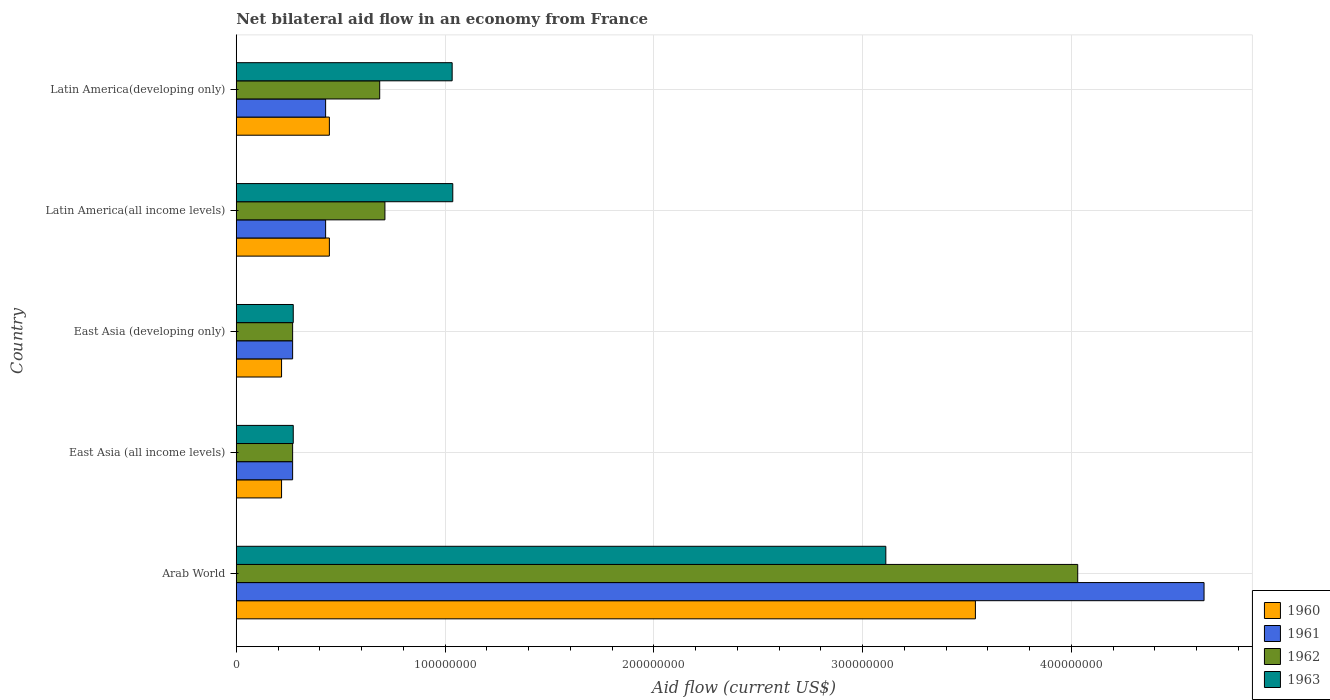How many bars are there on the 2nd tick from the top?
Make the answer very short. 4. How many bars are there on the 2nd tick from the bottom?
Your response must be concise. 4. What is the label of the 4th group of bars from the top?
Your answer should be compact. East Asia (all income levels). What is the net bilateral aid flow in 1962 in East Asia (all income levels)?
Offer a terse response. 2.70e+07. Across all countries, what is the maximum net bilateral aid flow in 1962?
Ensure brevity in your answer.  4.03e+08. Across all countries, what is the minimum net bilateral aid flow in 1960?
Offer a very short reply. 2.17e+07. In which country was the net bilateral aid flow in 1960 maximum?
Your answer should be very brief. Arab World. In which country was the net bilateral aid flow in 1960 minimum?
Give a very brief answer. East Asia (all income levels). What is the total net bilateral aid flow in 1962 in the graph?
Your response must be concise. 5.97e+08. What is the difference between the net bilateral aid flow in 1961 in East Asia (all income levels) and that in Latin America(all income levels)?
Provide a succinct answer. -1.58e+07. What is the difference between the net bilateral aid flow in 1963 in Arab World and the net bilateral aid flow in 1960 in East Asia (all income levels)?
Give a very brief answer. 2.89e+08. What is the average net bilateral aid flow in 1960 per country?
Your answer should be very brief. 9.73e+07. What is the difference between the net bilateral aid flow in 1961 and net bilateral aid flow in 1962 in East Asia (developing only)?
Your response must be concise. 0. What is the ratio of the net bilateral aid flow in 1960 in East Asia (all income levels) to that in East Asia (developing only)?
Your answer should be very brief. 1. Is the net bilateral aid flow in 1960 in Latin America(all income levels) less than that in Latin America(developing only)?
Provide a short and direct response. No. What is the difference between the highest and the second highest net bilateral aid flow in 1961?
Give a very brief answer. 4.21e+08. What is the difference between the highest and the lowest net bilateral aid flow in 1962?
Provide a succinct answer. 3.76e+08. What does the 2nd bar from the bottom in East Asia (developing only) represents?
Provide a short and direct response. 1961. What is the difference between two consecutive major ticks on the X-axis?
Make the answer very short. 1.00e+08. Does the graph contain grids?
Provide a succinct answer. Yes. How many legend labels are there?
Your answer should be very brief. 4. What is the title of the graph?
Your answer should be compact. Net bilateral aid flow in an economy from France. Does "1981" appear as one of the legend labels in the graph?
Provide a short and direct response. No. What is the label or title of the X-axis?
Keep it short and to the point. Aid flow (current US$). What is the label or title of the Y-axis?
Offer a terse response. Country. What is the Aid flow (current US$) in 1960 in Arab World?
Keep it short and to the point. 3.54e+08. What is the Aid flow (current US$) in 1961 in Arab World?
Your answer should be compact. 4.64e+08. What is the Aid flow (current US$) in 1962 in Arab World?
Ensure brevity in your answer.  4.03e+08. What is the Aid flow (current US$) in 1963 in Arab World?
Ensure brevity in your answer.  3.11e+08. What is the Aid flow (current US$) in 1960 in East Asia (all income levels)?
Ensure brevity in your answer.  2.17e+07. What is the Aid flow (current US$) of 1961 in East Asia (all income levels)?
Make the answer very short. 2.70e+07. What is the Aid flow (current US$) in 1962 in East Asia (all income levels)?
Provide a succinct answer. 2.70e+07. What is the Aid flow (current US$) in 1963 in East Asia (all income levels)?
Make the answer very short. 2.73e+07. What is the Aid flow (current US$) of 1960 in East Asia (developing only)?
Make the answer very short. 2.17e+07. What is the Aid flow (current US$) in 1961 in East Asia (developing only)?
Provide a succinct answer. 2.70e+07. What is the Aid flow (current US$) in 1962 in East Asia (developing only)?
Give a very brief answer. 2.70e+07. What is the Aid flow (current US$) in 1963 in East Asia (developing only)?
Your answer should be compact. 2.73e+07. What is the Aid flow (current US$) of 1960 in Latin America(all income levels)?
Make the answer very short. 4.46e+07. What is the Aid flow (current US$) of 1961 in Latin America(all income levels)?
Ensure brevity in your answer.  4.28e+07. What is the Aid flow (current US$) in 1962 in Latin America(all income levels)?
Offer a very short reply. 7.12e+07. What is the Aid flow (current US$) of 1963 in Latin America(all income levels)?
Your answer should be compact. 1.04e+08. What is the Aid flow (current US$) in 1960 in Latin America(developing only)?
Provide a succinct answer. 4.46e+07. What is the Aid flow (current US$) of 1961 in Latin America(developing only)?
Provide a short and direct response. 4.28e+07. What is the Aid flow (current US$) of 1962 in Latin America(developing only)?
Provide a succinct answer. 6.87e+07. What is the Aid flow (current US$) in 1963 in Latin America(developing only)?
Your answer should be compact. 1.03e+08. Across all countries, what is the maximum Aid flow (current US$) in 1960?
Make the answer very short. 3.54e+08. Across all countries, what is the maximum Aid flow (current US$) of 1961?
Offer a terse response. 4.64e+08. Across all countries, what is the maximum Aid flow (current US$) of 1962?
Give a very brief answer. 4.03e+08. Across all countries, what is the maximum Aid flow (current US$) of 1963?
Make the answer very short. 3.11e+08. Across all countries, what is the minimum Aid flow (current US$) in 1960?
Give a very brief answer. 2.17e+07. Across all countries, what is the minimum Aid flow (current US$) in 1961?
Provide a short and direct response. 2.70e+07. Across all countries, what is the minimum Aid flow (current US$) of 1962?
Your answer should be compact. 2.70e+07. Across all countries, what is the minimum Aid flow (current US$) of 1963?
Offer a terse response. 2.73e+07. What is the total Aid flow (current US$) in 1960 in the graph?
Give a very brief answer. 4.87e+08. What is the total Aid flow (current US$) of 1961 in the graph?
Keep it short and to the point. 6.03e+08. What is the total Aid flow (current US$) in 1962 in the graph?
Make the answer very short. 5.97e+08. What is the total Aid flow (current US$) of 1963 in the graph?
Your answer should be very brief. 5.73e+08. What is the difference between the Aid flow (current US$) of 1960 in Arab World and that in East Asia (all income levels)?
Offer a very short reply. 3.32e+08. What is the difference between the Aid flow (current US$) of 1961 in Arab World and that in East Asia (all income levels)?
Offer a very short reply. 4.36e+08. What is the difference between the Aid flow (current US$) of 1962 in Arab World and that in East Asia (all income levels)?
Provide a succinct answer. 3.76e+08. What is the difference between the Aid flow (current US$) in 1963 in Arab World and that in East Asia (all income levels)?
Give a very brief answer. 2.84e+08. What is the difference between the Aid flow (current US$) in 1960 in Arab World and that in East Asia (developing only)?
Provide a succinct answer. 3.32e+08. What is the difference between the Aid flow (current US$) of 1961 in Arab World and that in East Asia (developing only)?
Your answer should be compact. 4.36e+08. What is the difference between the Aid flow (current US$) in 1962 in Arab World and that in East Asia (developing only)?
Offer a terse response. 3.76e+08. What is the difference between the Aid flow (current US$) of 1963 in Arab World and that in East Asia (developing only)?
Provide a short and direct response. 2.84e+08. What is the difference between the Aid flow (current US$) of 1960 in Arab World and that in Latin America(all income levels)?
Your response must be concise. 3.09e+08. What is the difference between the Aid flow (current US$) in 1961 in Arab World and that in Latin America(all income levels)?
Your response must be concise. 4.21e+08. What is the difference between the Aid flow (current US$) in 1962 in Arab World and that in Latin America(all income levels)?
Provide a succinct answer. 3.32e+08. What is the difference between the Aid flow (current US$) of 1963 in Arab World and that in Latin America(all income levels)?
Your response must be concise. 2.07e+08. What is the difference between the Aid flow (current US$) in 1960 in Arab World and that in Latin America(developing only)?
Provide a short and direct response. 3.09e+08. What is the difference between the Aid flow (current US$) of 1961 in Arab World and that in Latin America(developing only)?
Keep it short and to the point. 4.21e+08. What is the difference between the Aid flow (current US$) of 1962 in Arab World and that in Latin America(developing only)?
Keep it short and to the point. 3.34e+08. What is the difference between the Aid flow (current US$) in 1963 in Arab World and that in Latin America(developing only)?
Your answer should be very brief. 2.08e+08. What is the difference between the Aid flow (current US$) of 1960 in East Asia (all income levels) and that in East Asia (developing only)?
Ensure brevity in your answer.  0. What is the difference between the Aid flow (current US$) in 1961 in East Asia (all income levels) and that in East Asia (developing only)?
Provide a succinct answer. 0. What is the difference between the Aid flow (current US$) of 1962 in East Asia (all income levels) and that in East Asia (developing only)?
Keep it short and to the point. 0. What is the difference between the Aid flow (current US$) of 1963 in East Asia (all income levels) and that in East Asia (developing only)?
Offer a terse response. 0. What is the difference between the Aid flow (current US$) in 1960 in East Asia (all income levels) and that in Latin America(all income levels)?
Give a very brief answer. -2.29e+07. What is the difference between the Aid flow (current US$) in 1961 in East Asia (all income levels) and that in Latin America(all income levels)?
Your answer should be very brief. -1.58e+07. What is the difference between the Aid flow (current US$) in 1962 in East Asia (all income levels) and that in Latin America(all income levels)?
Ensure brevity in your answer.  -4.42e+07. What is the difference between the Aid flow (current US$) of 1963 in East Asia (all income levels) and that in Latin America(all income levels)?
Provide a short and direct response. -7.64e+07. What is the difference between the Aid flow (current US$) in 1960 in East Asia (all income levels) and that in Latin America(developing only)?
Keep it short and to the point. -2.29e+07. What is the difference between the Aid flow (current US$) in 1961 in East Asia (all income levels) and that in Latin America(developing only)?
Your answer should be compact. -1.58e+07. What is the difference between the Aid flow (current US$) in 1962 in East Asia (all income levels) and that in Latin America(developing only)?
Your answer should be very brief. -4.17e+07. What is the difference between the Aid flow (current US$) of 1963 in East Asia (all income levels) and that in Latin America(developing only)?
Your answer should be very brief. -7.61e+07. What is the difference between the Aid flow (current US$) of 1960 in East Asia (developing only) and that in Latin America(all income levels)?
Your answer should be compact. -2.29e+07. What is the difference between the Aid flow (current US$) of 1961 in East Asia (developing only) and that in Latin America(all income levels)?
Provide a short and direct response. -1.58e+07. What is the difference between the Aid flow (current US$) of 1962 in East Asia (developing only) and that in Latin America(all income levels)?
Ensure brevity in your answer.  -4.42e+07. What is the difference between the Aid flow (current US$) in 1963 in East Asia (developing only) and that in Latin America(all income levels)?
Provide a short and direct response. -7.64e+07. What is the difference between the Aid flow (current US$) of 1960 in East Asia (developing only) and that in Latin America(developing only)?
Ensure brevity in your answer.  -2.29e+07. What is the difference between the Aid flow (current US$) of 1961 in East Asia (developing only) and that in Latin America(developing only)?
Provide a succinct answer. -1.58e+07. What is the difference between the Aid flow (current US$) of 1962 in East Asia (developing only) and that in Latin America(developing only)?
Provide a succinct answer. -4.17e+07. What is the difference between the Aid flow (current US$) in 1963 in East Asia (developing only) and that in Latin America(developing only)?
Your answer should be very brief. -7.61e+07. What is the difference between the Aid flow (current US$) of 1960 in Latin America(all income levels) and that in Latin America(developing only)?
Your answer should be compact. 0. What is the difference between the Aid flow (current US$) of 1962 in Latin America(all income levels) and that in Latin America(developing only)?
Ensure brevity in your answer.  2.50e+06. What is the difference between the Aid flow (current US$) of 1960 in Arab World and the Aid flow (current US$) of 1961 in East Asia (all income levels)?
Your response must be concise. 3.27e+08. What is the difference between the Aid flow (current US$) in 1960 in Arab World and the Aid flow (current US$) in 1962 in East Asia (all income levels)?
Keep it short and to the point. 3.27e+08. What is the difference between the Aid flow (current US$) in 1960 in Arab World and the Aid flow (current US$) in 1963 in East Asia (all income levels)?
Provide a short and direct response. 3.27e+08. What is the difference between the Aid flow (current US$) in 1961 in Arab World and the Aid flow (current US$) in 1962 in East Asia (all income levels)?
Give a very brief answer. 4.36e+08. What is the difference between the Aid flow (current US$) of 1961 in Arab World and the Aid flow (current US$) of 1963 in East Asia (all income levels)?
Your answer should be compact. 4.36e+08. What is the difference between the Aid flow (current US$) of 1962 in Arab World and the Aid flow (current US$) of 1963 in East Asia (all income levels)?
Ensure brevity in your answer.  3.76e+08. What is the difference between the Aid flow (current US$) in 1960 in Arab World and the Aid flow (current US$) in 1961 in East Asia (developing only)?
Make the answer very short. 3.27e+08. What is the difference between the Aid flow (current US$) in 1960 in Arab World and the Aid flow (current US$) in 1962 in East Asia (developing only)?
Ensure brevity in your answer.  3.27e+08. What is the difference between the Aid flow (current US$) in 1960 in Arab World and the Aid flow (current US$) in 1963 in East Asia (developing only)?
Your answer should be compact. 3.27e+08. What is the difference between the Aid flow (current US$) in 1961 in Arab World and the Aid flow (current US$) in 1962 in East Asia (developing only)?
Your response must be concise. 4.36e+08. What is the difference between the Aid flow (current US$) in 1961 in Arab World and the Aid flow (current US$) in 1963 in East Asia (developing only)?
Ensure brevity in your answer.  4.36e+08. What is the difference between the Aid flow (current US$) of 1962 in Arab World and the Aid flow (current US$) of 1963 in East Asia (developing only)?
Your response must be concise. 3.76e+08. What is the difference between the Aid flow (current US$) of 1960 in Arab World and the Aid flow (current US$) of 1961 in Latin America(all income levels)?
Keep it short and to the point. 3.11e+08. What is the difference between the Aid flow (current US$) in 1960 in Arab World and the Aid flow (current US$) in 1962 in Latin America(all income levels)?
Provide a short and direct response. 2.83e+08. What is the difference between the Aid flow (current US$) of 1960 in Arab World and the Aid flow (current US$) of 1963 in Latin America(all income levels)?
Offer a terse response. 2.50e+08. What is the difference between the Aid flow (current US$) of 1961 in Arab World and the Aid flow (current US$) of 1962 in Latin America(all income levels)?
Offer a terse response. 3.92e+08. What is the difference between the Aid flow (current US$) of 1961 in Arab World and the Aid flow (current US$) of 1963 in Latin America(all income levels)?
Provide a succinct answer. 3.60e+08. What is the difference between the Aid flow (current US$) of 1962 in Arab World and the Aid flow (current US$) of 1963 in Latin America(all income levels)?
Offer a terse response. 2.99e+08. What is the difference between the Aid flow (current US$) of 1960 in Arab World and the Aid flow (current US$) of 1961 in Latin America(developing only)?
Make the answer very short. 3.11e+08. What is the difference between the Aid flow (current US$) in 1960 in Arab World and the Aid flow (current US$) in 1962 in Latin America(developing only)?
Your answer should be very brief. 2.85e+08. What is the difference between the Aid flow (current US$) of 1960 in Arab World and the Aid flow (current US$) of 1963 in Latin America(developing only)?
Offer a very short reply. 2.51e+08. What is the difference between the Aid flow (current US$) of 1961 in Arab World and the Aid flow (current US$) of 1962 in Latin America(developing only)?
Keep it short and to the point. 3.95e+08. What is the difference between the Aid flow (current US$) in 1961 in Arab World and the Aid flow (current US$) in 1963 in Latin America(developing only)?
Make the answer very short. 3.60e+08. What is the difference between the Aid flow (current US$) in 1962 in Arab World and the Aid flow (current US$) in 1963 in Latin America(developing only)?
Make the answer very short. 3.00e+08. What is the difference between the Aid flow (current US$) of 1960 in East Asia (all income levels) and the Aid flow (current US$) of 1961 in East Asia (developing only)?
Your answer should be very brief. -5.30e+06. What is the difference between the Aid flow (current US$) of 1960 in East Asia (all income levels) and the Aid flow (current US$) of 1962 in East Asia (developing only)?
Your answer should be very brief. -5.30e+06. What is the difference between the Aid flow (current US$) of 1960 in East Asia (all income levels) and the Aid flow (current US$) of 1963 in East Asia (developing only)?
Offer a very short reply. -5.60e+06. What is the difference between the Aid flow (current US$) in 1961 in East Asia (all income levels) and the Aid flow (current US$) in 1963 in East Asia (developing only)?
Your answer should be very brief. -3.00e+05. What is the difference between the Aid flow (current US$) of 1962 in East Asia (all income levels) and the Aid flow (current US$) of 1963 in East Asia (developing only)?
Give a very brief answer. -3.00e+05. What is the difference between the Aid flow (current US$) in 1960 in East Asia (all income levels) and the Aid flow (current US$) in 1961 in Latin America(all income levels)?
Offer a terse response. -2.11e+07. What is the difference between the Aid flow (current US$) of 1960 in East Asia (all income levels) and the Aid flow (current US$) of 1962 in Latin America(all income levels)?
Provide a short and direct response. -4.95e+07. What is the difference between the Aid flow (current US$) of 1960 in East Asia (all income levels) and the Aid flow (current US$) of 1963 in Latin America(all income levels)?
Your response must be concise. -8.20e+07. What is the difference between the Aid flow (current US$) in 1961 in East Asia (all income levels) and the Aid flow (current US$) in 1962 in Latin America(all income levels)?
Your response must be concise. -4.42e+07. What is the difference between the Aid flow (current US$) in 1961 in East Asia (all income levels) and the Aid flow (current US$) in 1963 in Latin America(all income levels)?
Provide a short and direct response. -7.67e+07. What is the difference between the Aid flow (current US$) of 1962 in East Asia (all income levels) and the Aid flow (current US$) of 1963 in Latin America(all income levels)?
Your response must be concise. -7.67e+07. What is the difference between the Aid flow (current US$) of 1960 in East Asia (all income levels) and the Aid flow (current US$) of 1961 in Latin America(developing only)?
Offer a terse response. -2.11e+07. What is the difference between the Aid flow (current US$) of 1960 in East Asia (all income levels) and the Aid flow (current US$) of 1962 in Latin America(developing only)?
Provide a succinct answer. -4.70e+07. What is the difference between the Aid flow (current US$) in 1960 in East Asia (all income levels) and the Aid flow (current US$) in 1963 in Latin America(developing only)?
Keep it short and to the point. -8.17e+07. What is the difference between the Aid flow (current US$) in 1961 in East Asia (all income levels) and the Aid flow (current US$) in 1962 in Latin America(developing only)?
Offer a terse response. -4.17e+07. What is the difference between the Aid flow (current US$) of 1961 in East Asia (all income levels) and the Aid flow (current US$) of 1963 in Latin America(developing only)?
Give a very brief answer. -7.64e+07. What is the difference between the Aid flow (current US$) of 1962 in East Asia (all income levels) and the Aid flow (current US$) of 1963 in Latin America(developing only)?
Ensure brevity in your answer.  -7.64e+07. What is the difference between the Aid flow (current US$) of 1960 in East Asia (developing only) and the Aid flow (current US$) of 1961 in Latin America(all income levels)?
Offer a very short reply. -2.11e+07. What is the difference between the Aid flow (current US$) of 1960 in East Asia (developing only) and the Aid flow (current US$) of 1962 in Latin America(all income levels)?
Keep it short and to the point. -4.95e+07. What is the difference between the Aid flow (current US$) of 1960 in East Asia (developing only) and the Aid flow (current US$) of 1963 in Latin America(all income levels)?
Give a very brief answer. -8.20e+07. What is the difference between the Aid flow (current US$) in 1961 in East Asia (developing only) and the Aid flow (current US$) in 1962 in Latin America(all income levels)?
Your answer should be compact. -4.42e+07. What is the difference between the Aid flow (current US$) in 1961 in East Asia (developing only) and the Aid flow (current US$) in 1963 in Latin America(all income levels)?
Ensure brevity in your answer.  -7.67e+07. What is the difference between the Aid flow (current US$) in 1962 in East Asia (developing only) and the Aid flow (current US$) in 1963 in Latin America(all income levels)?
Your answer should be compact. -7.67e+07. What is the difference between the Aid flow (current US$) of 1960 in East Asia (developing only) and the Aid flow (current US$) of 1961 in Latin America(developing only)?
Make the answer very short. -2.11e+07. What is the difference between the Aid flow (current US$) of 1960 in East Asia (developing only) and the Aid flow (current US$) of 1962 in Latin America(developing only)?
Provide a short and direct response. -4.70e+07. What is the difference between the Aid flow (current US$) in 1960 in East Asia (developing only) and the Aid flow (current US$) in 1963 in Latin America(developing only)?
Offer a terse response. -8.17e+07. What is the difference between the Aid flow (current US$) of 1961 in East Asia (developing only) and the Aid flow (current US$) of 1962 in Latin America(developing only)?
Ensure brevity in your answer.  -4.17e+07. What is the difference between the Aid flow (current US$) in 1961 in East Asia (developing only) and the Aid flow (current US$) in 1963 in Latin America(developing only)?
Provide a short and direct response. -7.64e+07. What is the difference between the Aid flow (current US$) in 1962 in East Asia (developing only) and the Aid flow (current US$) in 1963 in Latin America(developing only)?
Your answer should be very brief. -7.64e+07. What is the difference between the Aid flow (current US$) in 1960 in Latin America(all income levels) and the Aid flow (current US$) in 1961 in Latin America(developing only)?
Provide a succinct answer. 1.80e+06. What is the difference between the Aid flow (current US$) of 1960 in Latin America(all income levels) and the Aid flow (current US$) of 1962 in Latin America(developing only)?
Your answer should be very brief. -2.41e+07. What is the difference between the Aid flow (current US$) in 1960 in Latin America(all income levels) and the Aid flow (current US$) in 1963 in Latin America(developing only)?
Your response must be concise. -5.88e+07. What is the difference between the Aid flow (current US$) in 1961 in Latin America(all income levels) and the Aid flow (current US$) in 1962 in Latin America(developing only)?
Make the answer very short. -2.59e+07. What is the difference between the Aid flow (current US$) in 1961 in Latin America(all income levels) and the Aid flow (current US$) in 1963 in Latin America(developing only)?
Your answer should be very brief. -6.06e+07. What is the difference between the Aid flow (current US$) in 1962 in Latin America(all income levels) and the Aid flow (current US$) in 1963 in Latin America(developing only)?
Your response must be concise. -3.22e+07. What is the average Aid flow (current US$) of 1960 per country?
Ensure brevity in your answer.  9.73e+07. What is the average Aid flow (current US$) in 1961 per country?
Your answer should be compact. 1.21e+08. What is the average Aid flow (current US$) in 1962 per country?
Ensure brevity in your answer.  1.19e+08. What is the average Aid flow (current US$) in 1963 per country?
Make the answer very short. 1.15e+08. What is the difference between the Aid flow (current US$) in 1960 and Aid flow (current US$) in 1961 in Arab World?
Offer a very short reply. -1.10e+08. What is the difference between the Aid flow (current US$) of 1960 and Aid flow (current US$) of 1962 in Arab World?
Provide a succinct answer. -4.90e+07. What is the difference between the Aid flow (current US$) in 1960 and Aid flow (current US$) in 1963 in Arab World?
Keep it short and to the point. 4.29e+07. What is the difference between the Aid flow (current US$) of 1961 and Aid flow (current US$) of 1962 in Arab World?
Offer a very short reply. 6.05e+07. What is the difference between the Aid flow (current US$) in 1961 and Aid flow (current US$) in 1963 in Arab World?
Offer a terse response. 1.52e+08. What is the difference between the Aid flow (current US$) in 1962 and Aid flow (current US$) in 1963 in Arab World?
Your answer should be compact. 9.19e+07. What is the difference between the Aid flow (current US$) of 1960 and Aid flow (current US$) of 1961 in East Asia (all income levels)?
Keep it short and to the point. -5.30e+06. What is the difference between the Aid flow (current US$) in 1960 and Aid flow (current US$) in 1962 in East Asia (all income levels)?
Ensure brevity in your answer.  -5.30e+06. What is the difference between the Aid flow (current US$) of 1960 and Aid flow (current US$) of 1963 in East Asia (all income levels)?
Ensure brevity in your answer.  -5.60e+06. What is the difference between the Aid flow (current US$) of 1961 and Aid flow (current US$) of 1962 in East Asia (all income levels)?
Your response must be concise. 0. What is the difference between the Aid flow (current US$) of 1960 and Aid flow (current US$) of 1961 in East Asia (developing only)?
Provide a short and direct response. -5.30e+06. What is the difference between the Aid flow (current US$) of 1960 and Aid flow (current US$) of 1962 in East Asia (developing only)?
Ensure brevity in your answer.  -5.30e+06. What is the difference between the Aid flow (current US$) of 1960 and Aid flow (current US$) of 1963 in East Asia (developing only)?
Give a very brief answer. -5.60e+06. What is the difference between the Aid flow (current US$) in 1961 and Aid flow (current US$) in 1962 in East Asia (developing only)?
Ensure brevity in your answer.  0. What is the difference between the Aid flow (current US$) of 1961 and Aid flow (current US$) of 1963 in East Asia (developing only)?
Your response must be concise. -3.00e+05. What is the difference between the Aid flow (current US$) in 1962 and Aid flow (current US$) in 1963 in East Asia (developing only)?
Give a very brief answer. -3.00e+05. What is the difference between the Aid flow (current US$) of 1960 and Aid flow (current US$) of 1961 in Latin America(all income levels)?
Your response must be concise. 1.80e+06. What is the difference between the Aid flow (current US$) in 1960 and Aid flow (current US$) in 1962 in Latin America(all income levels)?
Your answer should be compact. -2.66e+07. What is the difference between the Aid flow (current US$) in 1960 and Aid flow (current US$) in 1963 in Latin America(all income levels)?
Provide a succinct answer. -5.91e+07. What is the difference between the Aid flow (current US$) in 1961 and Aid flow (current US$) in 1962 in Latin America(all income levels)?
Provide a short and direct response. -2.84e+07. What is the difference between the Aid flow (current US$) of 1961 and Aid flow (current US$) of 1963 in Latin America(all income levels)?
Give a very brief answer. -6.09e+07. What is the difference between the Aid flow (current US$) in 1962 and Aid flow (current US$) in 1963 in Latin America(all income levels)?
Ensure brevity in your answer.  -3.25e+07. What is the difference between the Aid flow (current US$) of 1960 and Aid flow (current US$) of 1961 in Latin America(developing only)?
Your response must be concise. 1.80e+06. What is the difference between the Aid flow (current US$) of 1960 and Aid flow (current US$) of 1962 in Latin America(developing only)?
Offer a terse response. -2.41e+07. What is the difference between the Aid flow (current US$) in 1960 and Aid flow (current US$) in 1963 in Latin America(developing only)?
Your response must be concise. -5.88e+07. What is the difference between the Aid flow (current US$) of 1961 and Aid flow (current US$) of 1962 in Latin America(developing only)?
Your answer should be very brief. -2.59e+07. What is the difference between the Aid flow (current US$) of 1961 and Aid flow (current US$) of 1963 in Latin America(developing only)?
Your response must be concise. -6.06e+07. What is the difference between the Aid flow (current US$) in 1962 and Aid flow (current US$) in 1963 in Latin America(developing only)?
Make the answer very short. -3.47e+07. What is the ratio of the Aid flow (current US$) of 1960 in Arab World to that in East Asia (all income levels)?
Your answer should be compact. 16.31. What is the ratio of the Aid flow (current US$) of 1961 in Arab World to that in East Asia (all income levels)?
Provide a succinct answer. 17.17. What is the ratio of the Aid flow (current US$) of 1962 in Arab World to that in East Asia (all income levels)?
Provide a succinct answer. 14.93. What is the ratio of the Aid flow (current US$) in 1963 in Arab World to that in East Asia (all income levels)?
Offer a terse response. 11.4. What is the ratio of the Aid flow (current US$) of 1960 in Arab World to that in East Asia (developing only)?
Your answer should be very brief. 16.31. What is the ratio of the Aid flow (current US$) in 1961 in Arab World to that in East Asia (developing only)?
Keep it short and to the point. 17.17. What is the ratio of the Aid flow (current US$) of 1962 in Arab World to that in East Asia (developing only)?
Your response must be concise. 14.93. What is the ratio of the Aid flow (current US$) in 1963 in Arab World to that in East Asia (developing only)?
Provide a succinct answer. 11.4. What is the ratio of the Aid flow (current US$) of 1960 in Arab World to that in Latin America(all income levels)?
Provide a succinct answer. 7.94. What is the ratio of the Aid flow (current US$) of 1961 in Arab World to that in Latin America(all income levels)?
Keep it short and to the point. 10.83. What is the ratio of the Aid flow (current US$) of 1962 in Arab World to that in Latin America(all income levels)?
Ensure brevity in your answer.  5.66. What is the ratio of the Aid flow (current US$) in 1960 in Arab World to that in Latin America(developing only)?
Provide a short and direct response. 7.94. What is the ratio of the Aid flow (current US$) of 1961 in Arab World to that in Latin America(developing only)?
Offer a very short reply. 10.83. What is the ratio of the Aid flow (current US$) of 1962 in Arab World to that in Latin America(developing only)?
Your answer should be very brief. 5.87. What is the ratio of the Aid flow (current US$) in 1963 in Arab World to that in Latin America(developing only)?
Provide a short and direct response. 3.01. What is the ratio of the Aid flow (current US$) in 1962 in East Asia (all income levels) to that in East Asia (developing only)?
Give a very brief answer. 1. What is the ratio of the Aid flow (current US$) in 1963 in East Asia (all income levels) to that in East Asia (developing only)?
Provide a succinct answer. 1. What is the ratio of the Aid flow (current US$) of 1960 in East Asia (all income levels) to that in Latin America(all income levels)?
Offer a very short reply. 0.49. What is the ratio of the Aid flow (current US$) of 1961 in East Asia (all income levels) to that in Latin America(all income levels)?
Give a very brief answer. 0.63. What is the ratio of the Aid flow (current US$) of 1962 in East Asia (all income levels) to that in Latin America(all income levels)?
Your answer should be compact. 0.38. What is the ratio of the Aid flow (current US$) in 1963 in East Asia (all income levels) to that in Latin America(all income levels)?
Give a very brief answer. 0.26. What is the ratio of the Aid flow (current US$) in 1960 in East Asia (all income levels) to that in Latin America(developing only)?
Your answer should be very brief. 0.49. What is the ratio of the Aid flow (current US$) in 1961 in East Asia (all income levels) to that in Latin America(developing only)?
Give a very brief answer. 0.63. What is the ratio of the Aid flow (current US$) in 1962 in East Asia (all income levels) to that in Latin America(developing only)?
Offer a very short reply. 0.39. What is the ratio of the Aid flow (current US$) in 1963 in East Asia (all income levels) to that in Latin America(developing only)?
Offer a very short reply. 0.26. What is the ratio of the Aid flow (current US$) in 1960 in East Asia (developing only) to that in Latin America(all income levels)?
Make the answer very short. 0.49. What is the ratio of the Aid flow (current US$) in 1961 in East Asia (developing only) to that in Latin America(all income levels)?
Keep it short and to the point. 0.63. What is the ratio of the Aid flow (current US$) in 1962 in East Asia (developing only) to that in Latin America(all income levels)?
Your answer should be very brief. 0.38. What is the ratio of the Aid flow (current US$) of 1963 in East Asia (developing only) to that in Latin America(all income levels)?
Ensure brevity in your answer.  0.26. What is the ratio of the Aid flow (current US$) in 1960 in East Asia (developing only) to that in Latin America(developing only)?
Your answer should be compact. 0.49. What is the ratio of the Aid flow (current US$) of 1961 in East Asia (developing only) to that in Latin America(developing only)?
Give a very brief answer. 0.63. What is the ratio of the Aid flow (current US$) of 1962 in East Asia (developing only) to that in Latin America(developing only)?
Ensure brevity in your answer.  0.39. What is the ratio of the Aid flow (current US$) of 1963 in East Asia (developing only) to that in Latin America(developing only)?
Your response must be concise. 0.26. What is the ratio of the Aid flow (current US$) of 1962 in Latin America(all income levels) to that in Latin America(developing only)?
Offer a very short reply. 1.04. What is the ratio of the Aid flow (current US$) of 1963 in Latin America(all income levels) to that in Latin America(developing only)?
Offer a very short reply. 1. What is the difference between the highest and the second highest Aid flow (current US$) in 1960?
Your answer should be very brief. 3.09e+08. What is the difference between the highest and the second highest Aid flow (current US$) in 1961?
Offer a terse response. 4.21e+08. What is the difference between the highest and the second highest Aid flow (current US$) in 1962?
Your answer should be very brief. 3.32e+08. What is the difference between the highest and the second highest Aid flow (current US$) of 1963?
Ensure brevity in your answer.  2.07e+08. What is the difference between the highest and the lowest Aid flow (current US$) of 1960?
Provide a succinct answer. 3.32e+08. What is the difference between the highest and the lowest Aid flow (current US$) of 1961?
Give a very brief answer. 4.36e+08. What is the difference between the highest and the lowest Aid flow (current US$) in 1962?
Your response must be concise. 3.76e+08. What is the difference between the highest and the lowest Aid flow (current US$) in 1963?
Ensure brevity in your answer.  2.84e+08. 